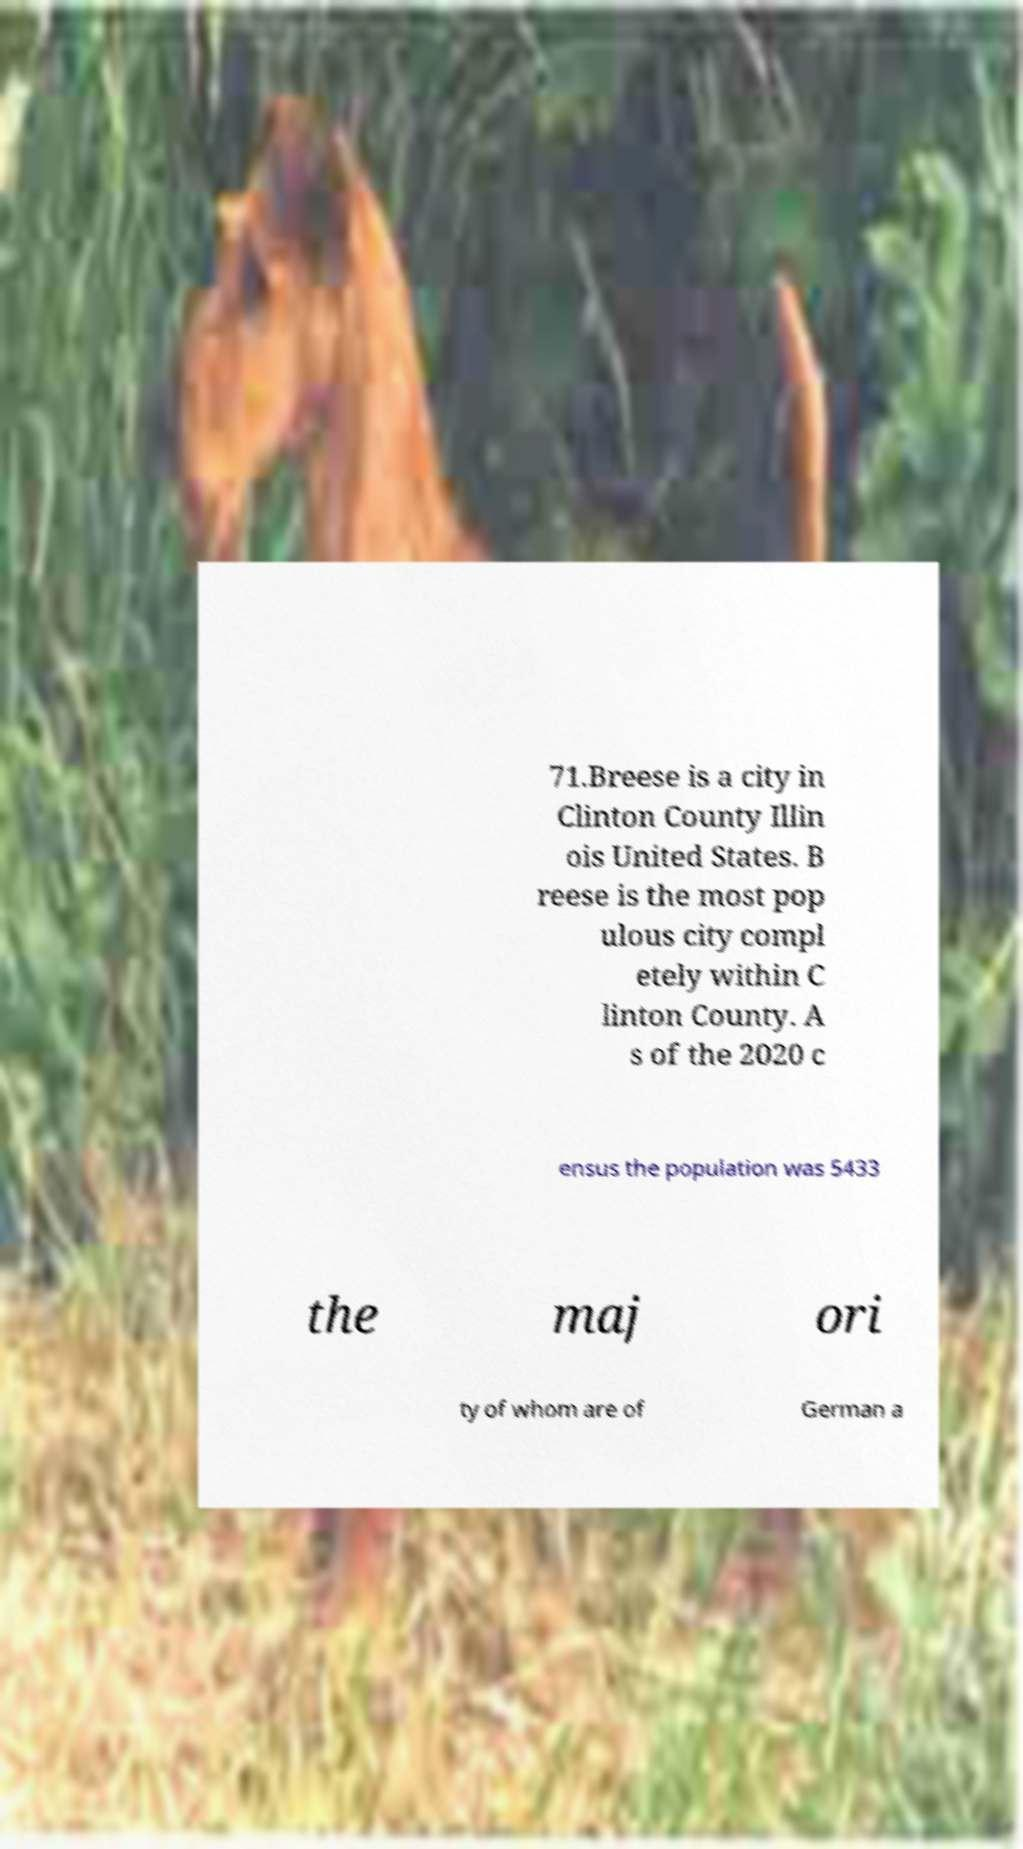Could you assist in decoding the text presented in this image and type it out clearly? 71.Breese is a city in Clinton County Illin ois United States. B reese is the most pop ulous city compl etely within C linton County. A s of the 2020 c ensus the population was 5433 the maj ori ty of whom are of German a 